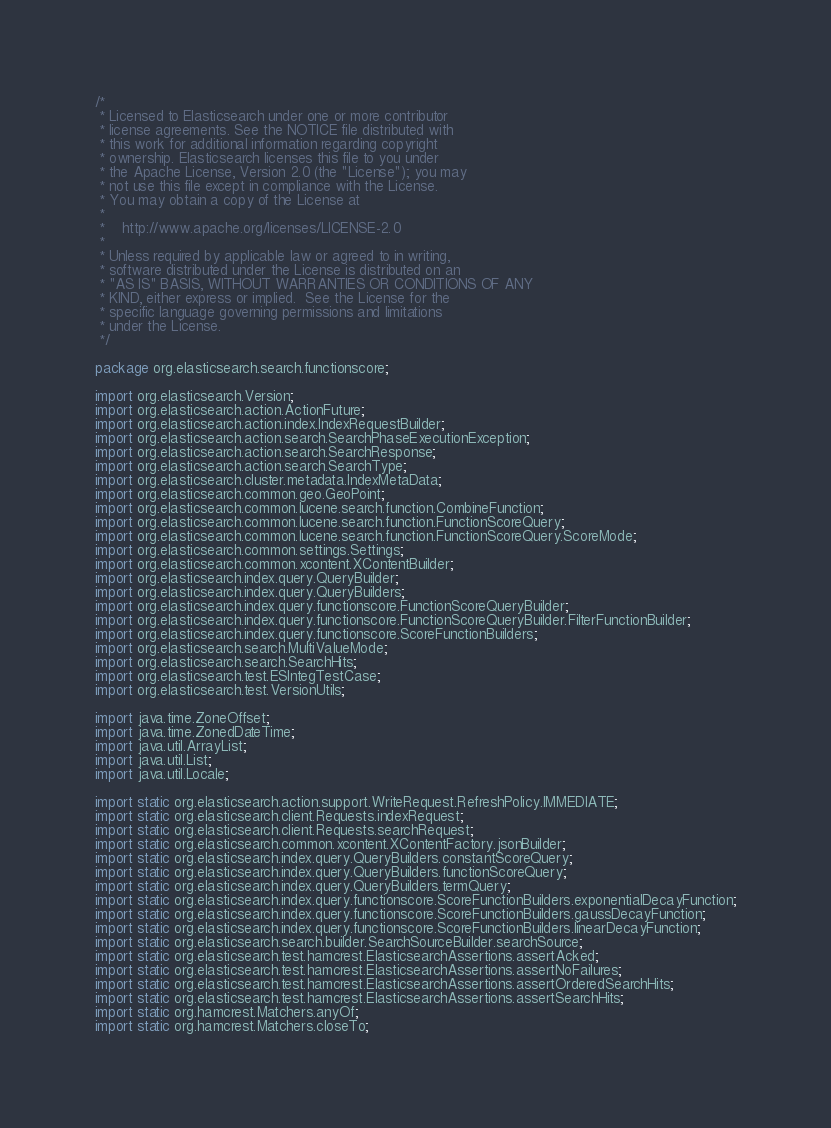Convert code to text. <code><loc_0><loc_0><loc_500><loc_500><_Java_>/*
 * Licensed to Elasticsearch under one or more contributor
 * license agreements. See the NOTICE file distributed with
 * this work for additional information regarding copyright
 * ownership. Elasticsearch licenses this file to you under
 * the Apache License, Version 2.0 (the "License"); you may
 * not use this file except in compliance with the License.
 * You may obtain a copy of the License at
 *
 *    http://www.apache.org/licenses/LICENSE-2.0
 *
 * Unless required by applicable law or agreed to in writing,
 * software distributed under the License is distributed on an
 * "AS IS" BASIS, WITHOUT WARRANTIES OR CONDITIONS OF ANY
 * KIND, either express or implied.  See the License for the
 * specific language governing permissions and limitations
 * under the License.
 */

package org.elasticsearch.search.functionscore;

import org.elasticsearch.Version;
import org.elasticsearch.action.ActionFuture;
import org.elasticsearch.action.index.IndexRequestBuilder;
import org.elasticsearch.action.search.SearchPhaseExecutionException;
import org.elasticsearch.action.search.SearchResponse;
import org.elasticsearch.action.search.SearchType;
import org.elasticsearch.cluster.metadata.IndexMetaData;
import org.elasticsearch.common.geo.GeoPoint;
import org.elasticsearch.common.lucene.search.function.CombineFunction;
import org.elasticsearch.common.lucene.search.function.FunctionScoreQuery;
import org.elasticsearch.common.lucene.search.function.FunctionScoreQuery.ScoreMode;
import org.elasticsearch.common.settings.Settings;
import org.elasticsearch.common.xcontent.XContentBuilder;
import org.elasticsearch.index.query.QueryBuilder;
import org.elasticsearch.index.query.QueryBuilders;
import org.elasticsearch.index.query.functionscore.FunctionScoreQueryBuilder;
import org.elasticsearch.index.query.functionscore.FunctionScoreQueryBuilder.FilterFunctionBuilder;
import org.elasticsearch.index.query.functionscore.ScoreFunctionBuilders;
import org.elasticsearch.search.MultiValueMode;
import org.elasticsearch.search.SearchHits;
import org.elasticsearch.test.ESIntegTestCase;
import org.elasticsearch.test.VersionUtils;

import java.time.ZoneOffset;
import java.time.ZonedDateTime;
import java.util.ArrayList;
import java.util.List;
import java.util.Locale;

import static org.elasticsearch.action.support.WriteRequest.RefreshPolicy.IMMEDIATE;
import static org.elasticsearch.client.Requests.indexRequest;
import static org.elasticsearch.client.Requests.searchRequest;
import static org.elasticsearch.common.xcontent.XContentFactory.jsonBuilder;
import static org.elasticsearch.index.query.QueryBuilders.constantScoreQuery;
import static org.elasticsearch.index.query.QueryBuilders.functionScoreQuery;
import static org.elasticsearch.index.query.QueryBuilders.termQuery;
import static org.elasticsearch.index.query.functionscore.ScoreFunctionBuilders.exponentialDecayFunction;
import static org.elasticsearch.index.query.functionscore.ScoreFunctionBuilders.gaussDecayFunction;
import static org.elasticsearch.index.query.functionscore.ScoreFunctionBuilders.linearDecayFunction;
import static org.elasticsearch.search.builder.SearchSourceBuilder.searchSource;
import static org.elasticsearch.test.hamcrest.ElasticsearchAssertions.assertAcked;
import static org.elasticsearch.test.hamcrest.ElasticsearchAssertions.assertNoFailures;
import static org.elasticsearch.test.hamcrest.ElasticsearchAssertions.assertOrderedSearchHits;
import static org.elasticsearch.test.hamcrest.ElasticsearchAssertions.assertSearchHits;
import static org.hamcrest.Matchers.anyOf;
import static org.hamcrest.Matchers.closeTo;</code> 